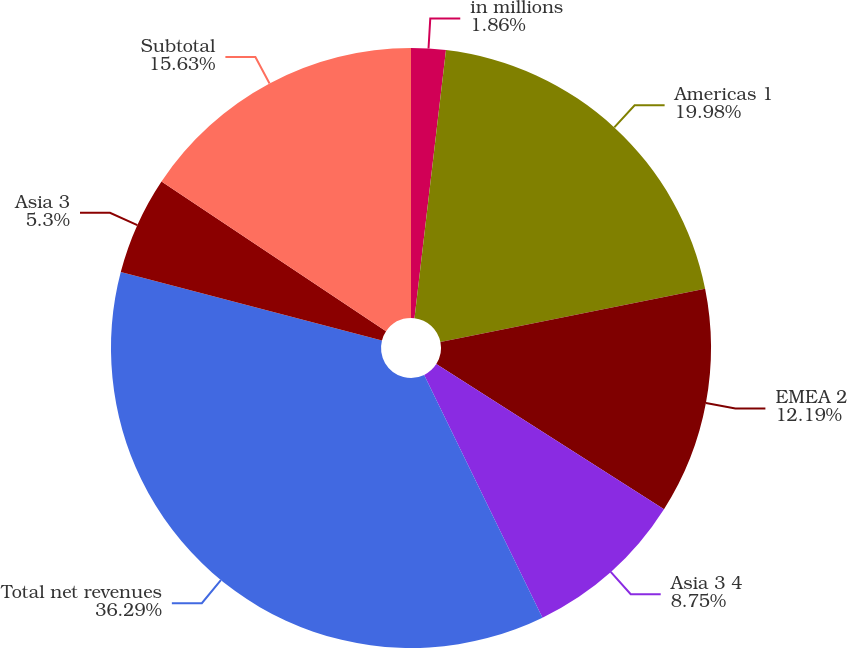<chart> <loc_0><loc_0><loc_500><loc_500><pie_chart><fcel>in millions<fcel>Americas 1<fcel>EMEA 2<fcel>Asia 3 4<fcel>Total net revenues<fcel>Asia 3<fcel>Subtotal<nl><fcel>1.86%<fcel>19.98%<fcel>12.19%<fcel>8.75%<fcel>36.29%<fcel>5.3%<fcel>15.63%<nl></chart> 